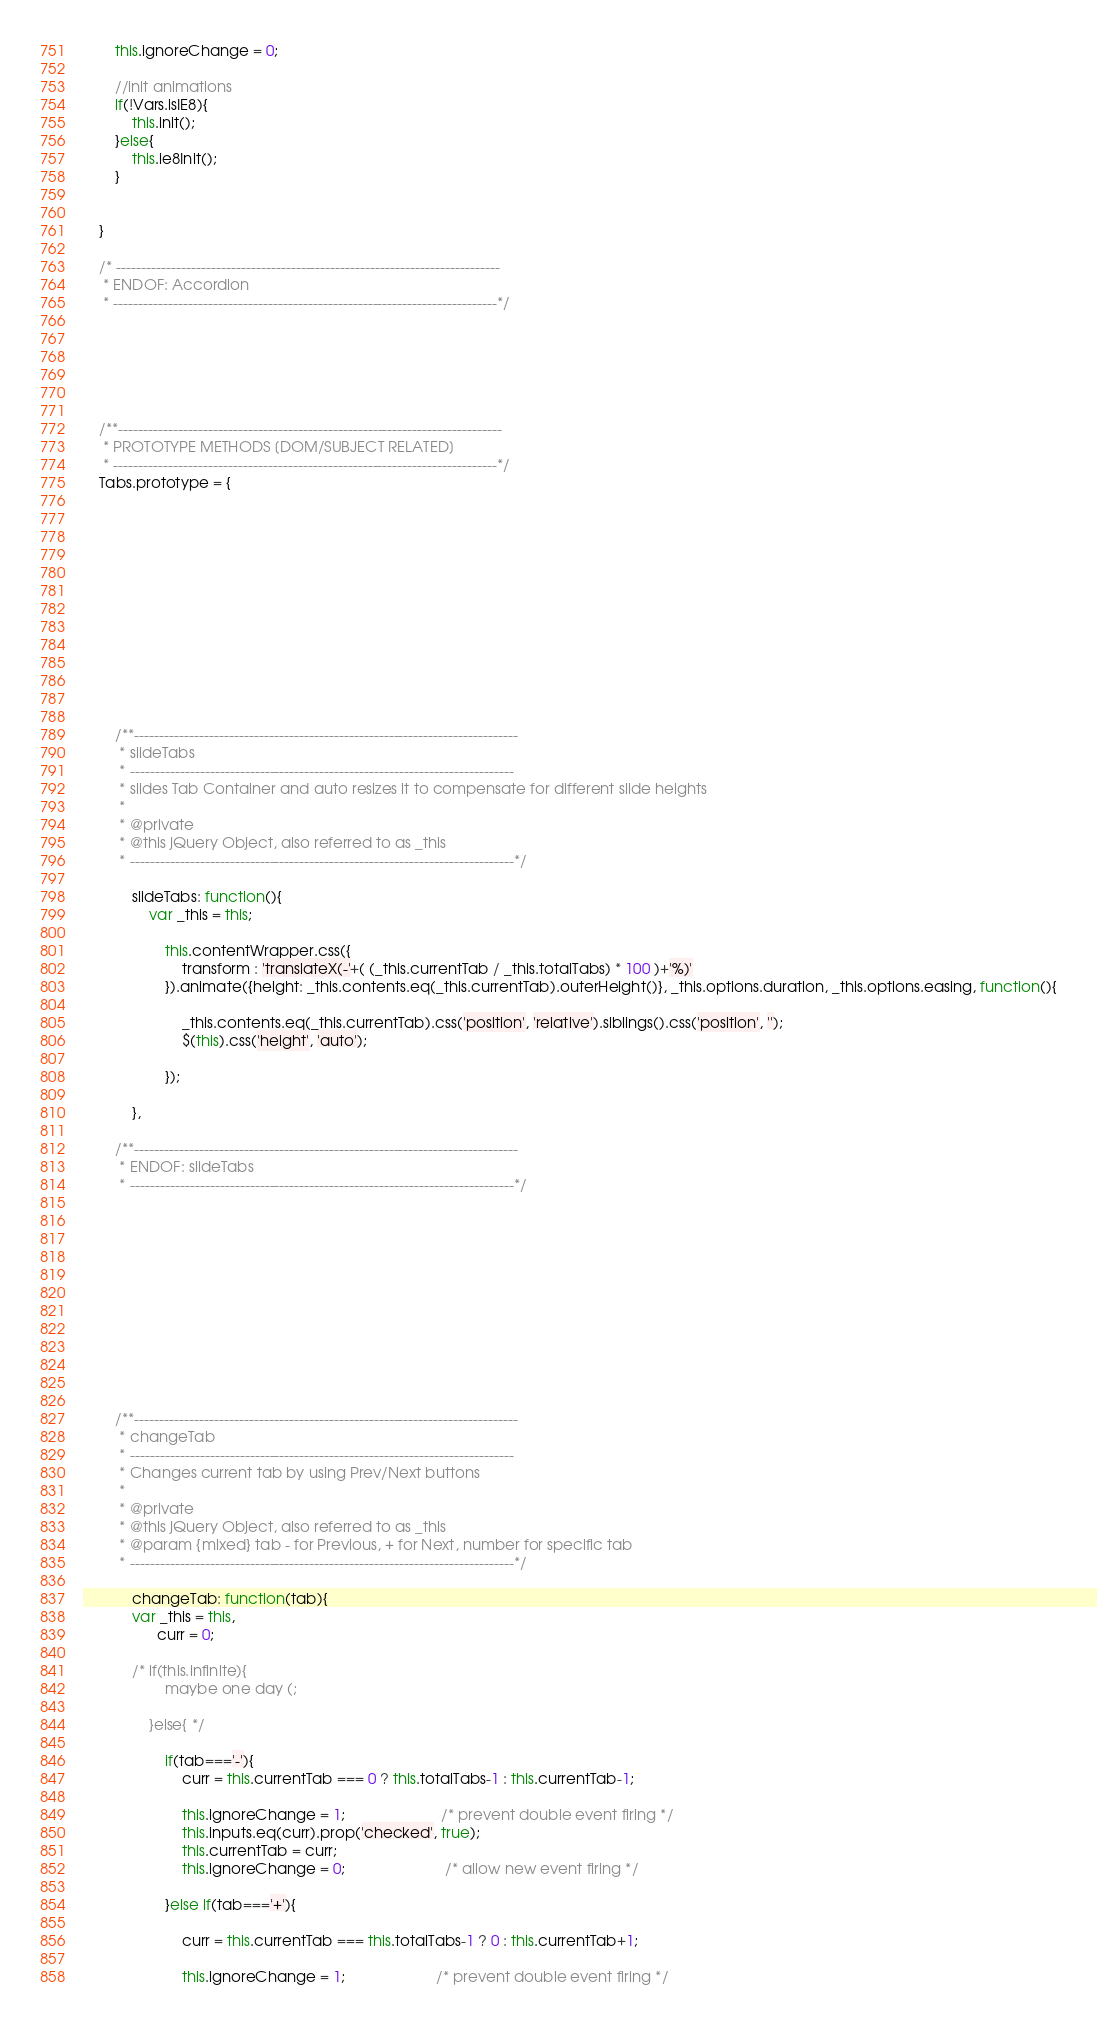Convert code to text. <code><loc_0><loc_0><loc_500><loc_500><_JavaScript_>		this.ignoreChange = 0;

		//init animations
		if(!Vars.isIE8){
			this.init();
		}else{
			this.ie8Init();
		}


	}

	/* -----------------------------------------------------------------------------
	 * ENDOF: Accordion
	 * -----------------------------------------------------------------------------*/






	/**-----------------------------------------------------------------------------
	 * PROTOTYPE METHODS [DOM/SUBJECT RELATED]
	 * -----------------------------------------------------------------------------*/
	Tabs.prototype = {













		/**-----------------------------------------------------------------------------
		 * slideTabs
		 * -----------------------------------------------------------------------------
		 * slides Tab Container and auto resizes it to compensate for different slide heights
		 *
		 * @private
		 * @this jQuery Object, also referred to as _this
		 * -----------------------------------------------------------------------------*/

			slideTabs: function(){
				var _this = this;

					this.contentWrapper.css({
						transform : 'translateX(-'+( (_this.currentTab / _this.totalTabs) * 100 )+'%)'
					}).animate({height: _this.contents.eq(_this.currentTab).outerHeight()}, _this.options.duration, _this.options.easing, function(){

						_this.contents.eq(_this.currentTab).css('position', 'relative').siblings().css('position', '');
						$(this).css('height', 'auto');

					});

			},

		/**-----------------------------------------------------------------------------
		 * ENDOF: slideTabs
		 * -----------------------------------------------------------------------------*/












		/**-----------------------------------------------------------------------------
		 * changeTab
		 * -----------------------------------------------------------------------------
		 * Changes current tab by using Prev/Next buttons
		 *
		 * @private
		 * @this jQuery Object, also referred to as _this
		 * @param {mixed} tab - for Previous, + for Next, number for specific tab
		 * -----------------------------------------------------------------------------*/

			changeTab: function(tab){
		    var _this = this,
			      curr = 0;

			/* if(this.infinite){
					maybe one day (;

				}else{ */

					if(tab==='-'){
						curr = this.currentTab === 0 ? this.totalTabs-1 : this.currentTab-1;

						this.ignoreChange = 1;                       /* prevent double event firing */
						this.inputs.eq(curr).prop('checked', true);
						this.currentTab = curr;
						this.ignoreChange = 0;                        /* allow new event firing */

					}else if(tab==='+'){

						curr = this.currentTab === this.totalTabs-1 ? 0 : this.currentTab+1;

						this.ignoreChange = 1;                      /* prevent double event firing */</code> 